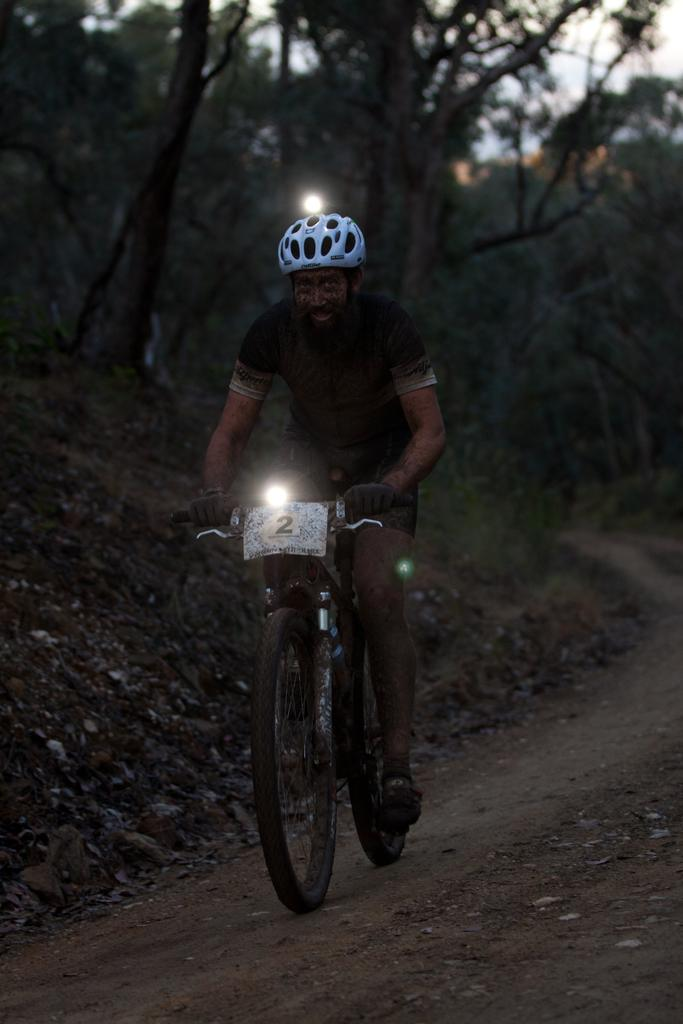What is the man in the image doing? The man is riding a bicycle. What safety precaution is the man taking while riding the bicycle? The man is wearing a helmet. What feature does the helmet have? The helmet has a light. What is attached to the bicycle? There is a board on the bicycle. Does the bicycle have any lighting features? Yes, the bicycle has a light. What can be seen in the background of the image? There are trees, grass, and the sky visible in the background of the image. Where is the sink located in the image? There is no sink present in the image; it features a man riding a bicycle with a helmet and a light. 